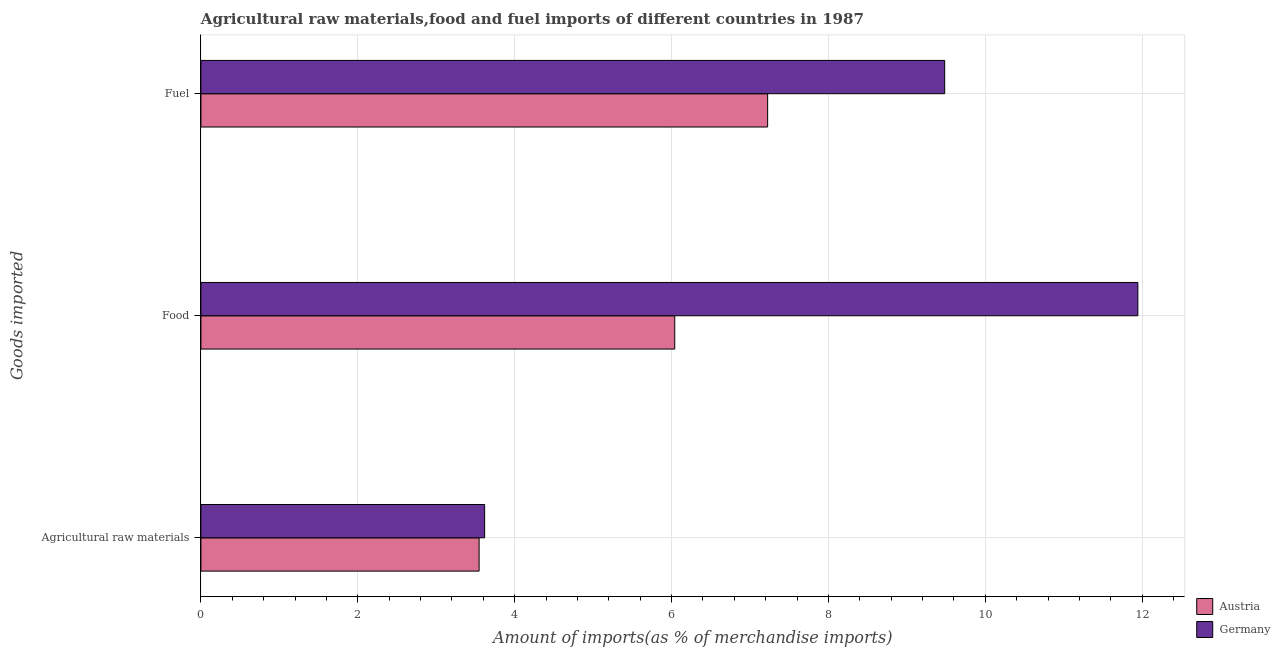How many groups of bars are there?
Make the answer very short. 3. How many bars are there on the 2nd tick from the bottom?
Give a very brief answer. 2. What is the label of the 1st group of bars from the top?
Your answer should be compact. Fuel. What is the percentage of raw materials imports in Austria?
Offer a very short reply. 3.55. Across all countries, what is the maximum percentage of food imports?
Keep it short and to the point. 11.95. Across all countries, what is the minimum percentage of food imports?
Make the answer very short. 6.04. In which country was the percentage of raw materials imports maximum?
Your answer should be compact. Germany. What is the total percentage of fuel imports in the graph?
Offer a very short reply. 16.71. What is the difference between the percentage of food imports in Austria and that in Germany?
Ensure brevity in your answer.  -5.9. What is the difference between the percentage of food imports in Germany and the percentage of fuel imports in Austria?
Keep it short and to the point. 4.72. What is the average percentage of food imports per country?
Give a very brief answer. 8.99. What is the difference between the percentage of fuel imports and percentage of food imports in Germany?
Offer a very short reply. -2.46. What is the ratio of the percentage of raw materials imports in Germany to that in Austria?
Provide a short and direct response. 1.02. Is the difference between the percentage of raw materials imports in Germany and Austria greater than the difference between the percentage of fuel imports in Germany and Austria?
Provide a succinct answer. No. What is the difference between the highest and the second highest percentage of raw materials imports?
Ensure brevity in your answer.  0.07. What is the difference between the highest and the lowest percentage of food imports?
Ensure brevity in your answer.  5.9. In how many countries, is the percentage of raw materials imports greater than the average percentage of raw materials imports taken over all countries?
Keep it short and to the point. 1. Is it the case that in every country, the sum of the percentage of raw materials imports and percentage of food imports is greater than the percentage of fuel imports?
Your answer should be compact. Yes. How many bars are there?
Your answer should be compact. 6. Are all the bars in the graph horizontal?
Provide a short and direct response. Yes. How many countries are there in the graph?
Offer a terse response. 2. Are the values on the major ticks of X-axis written in scientific E-notation?
Your answer should be compact. No. Does the graph contain grids?
Keep it short and to the point. Yes. Where does the legend appear in the graph?
Your answer should be very brief. Bottom right. How are the legend labels stacked?
Give a very brief answer. Vertical. What is the title of the graph?
Your response must be concise. Agricultural raw materials,food and fuel imports of different countries in 1987. Does "Vanuatu" appear as one of the legend labels in the graph?
Ensure brevity in your answer.  No. What is the label or title of the X-axis?
Keep it short and to the point. Amount of imports(as % of merchandise imports). What is the label or title of the Y-axis?
Give a very brief answer. Goods imported. What is the Amount of imports(as % of merchandise imports) of Austria in Agricultural raw materials?
Offer a very short reply. 3.55. What is the Amount of imports(as % of merchandise imports) of Germany in Agricultural raw materials?
Provide a short and direct response. 3.62. What is the Amount of imports(as % of merchandise imports) in Austria in Food?
Make the answer very short. 6.04. What is the Amount of imports(as % of merchandise imports) in Germany in Food?
Your answer should be very brief. 11.95. What is the Amount of imports(as % of merchandise imports) in Austria in Fuel?
Provide a short and direct response. 7.23. What is the Amount of imports(as % of merchandise imports) of Germany in Fuel?
Your answer should be very brief. 9.48. Across all Goods imported, what is the maximum Amount of imports(as % of merchandise imports) in Austria?
Offer a very short reply. 7.23. Across all Goods imported, what is the maximum Amount of imports(as % of merchandise imports) in Germany?
Your answer should be very brief. 11.95. Across all Goods imported, what is the minimum Amount of imports(as % of merchandise imports) of Austria?
Your response must be concise. 3.55. Across all Goods imported, what is the minimum Amount of imports(as % of merchandise imports) of Germany?
Give a very brief answer. 3.62. What is the total Amount of imports(as % of merchandise imports) of Austria in the graph?
Offer a very short reply. 16.81. What is the total Amount of imports(as % of merchandise imports) of Germany in the graph?
Offer a very short reply. 25.05. What is the difference between the Amount of imports(as % of merchandise imports) in Austria in Agricultural raw materials and that in Food?
Provide a short and direct response. -2.49. What is the difference between the Amount of imports(as % of merchandise imports) in Germany in Agricultural raw materials and that in Food?
Offer a terse response. -8.33. What is the difference between the Amount of imports(as % of merchandise imports) in Austria in Agricultural raw materials and that in Fuel?
Your answer should be very brief. -3.68. What is the difference between the Amount of imports(as % of merchandise imports) of Germany in Agricultural raw materials and that in Fuel?
Provide a short and direct response. -5.87. What is the difference between the Amount of imports(as % of merchandise imports) in Austria in Food and that in Fuel?
Give a very brief answer. -1.18. What is the difference between the Amount of imports(as % of merchandise imports) in Germany in Food and that in Fuel?
Offer a terse response. 2.46. What is the difference between the Amount of imports(as % of merchandise imports) in Austria in Agricultural raw materials and the Amount of imports(as % of merchandise imports) in Germany in Food?
Your response must be concise. -8.4. What is the difference between the Amount of imports(as % of merchandise imports) of Austria in Agricultural raw materials and the Amount of imports(as % of merchandise imports) of Germany in Fuel?
Your answer should be very brief. -5.94. What is the difference between the Amount of imports(as % of merchandise imports) in Austria in Food and the Amount of imports(as % of merchandise imports) in Germany in Fuel?
Ensure brevity in your answer.  -3.44. What is the average Amount of imports(as % of merchandise imports) in Austria per Goods imported?
Offer a very short reply. 5.6. What is the average Amount of imports(as % of merchandise imports) of Germany per Goods imported?
Ensure brevity in your answer.  8.35. What is the difference between the Amount of imports(as % of merchandise imports) of Austria and Amount of imports(as % of merchandise imports) of Germany in Agricultural raw materials?
Ensure brevity in your answer.  -0.07. What is the difference between the Amount of imports(as % of merchandise imports) of Austria and Amount of imports(as % of merchandise imports) of Germany in Food?
Your answer should be compact. -5.9. What is the difference between the Amount of imports(as % of merchandise imports) in Austria and Amount of imports(as % of merchandise imports) in Germany in Fuel?
Make the answer very short. -2.26. What is the ratio of the Amount of imports(as % of merchandise imports) of Austria in Agricultural raw materials to that in Food?
Your answer should be compact. 0.59. What is the ratio of the Amount of imports(as % of merchandise imports) of Germany in Agricultural raw materials to that in Food?
Provide a succinct answer. 0.3. What is the ratio of the Amount of imports(as % of merchandise imports) in Austria in Agricultural raw materials to that in Fuel?
Your answer should be very brief. 0.49. What is the ratio of the Amount of imports(as % of merchandise imports) of Germany in Agricultural raw materials to that in Fuel?
Offer a terse response. 0.38. What is the ratio of the Amount of imports(as % of merchandise imports) in Austria in Food to that in Fuel?
Your answer should be very brief. 0.84. What is the ratio of the Amount of imports(as % of merchandise imports) of Germany in Food to that in Fuel?
Your answer should be very brief. 1.26. What is the difference between the highest and the second highest Amount of imports(as % of merchandise imports) in Austria?
Your answer should be very brief. 1.18. What is the difference between the highest and the second highest Amount of imports(as % of merchandise imports) in Germany?
Provide a short and direct response. 2.46. What is the difference between the highest and the lowest Amount of imports(as % of merchandise imports) of Austria?
Provide a short and direct response. 3.68. What is the difference between the highest and the lowest Amount of imports(as % of merchandise imports) of Germany?
Keep it short and to the point. 8.33. 